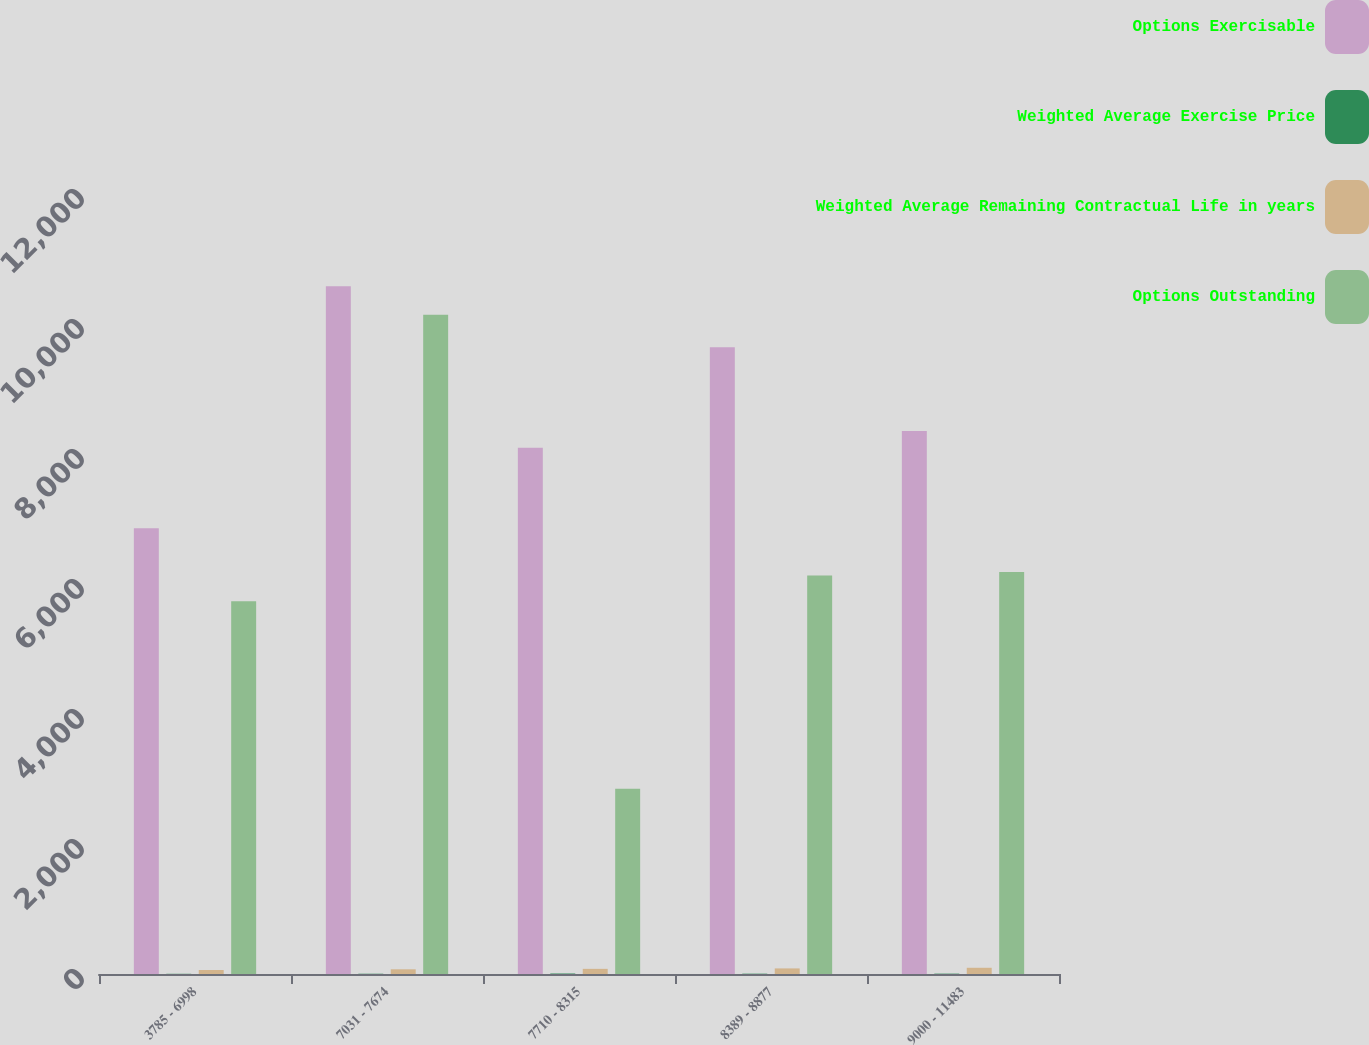Convert chart. <chart><loc_0><loc_0><loc_500><loc_500><stacked_bar_chart><ecel><fcel>3785 - 6998<fcel>7031 - 7674<fcel>7710 - 8315<fcel>8389 - 8877<fcel>9000 - 11483<nl><fcel>Options Exercisable<fcel>6859<fcel>10579<fcel>8095<fcel>9644<fcel>8352<nl><fcel>Weighted Average Exercise Price<fcel>3<fcel>4.1<fcel>7.5<fcel>5<fcel>5.5<nl><fcel>Weighted Average Remaining Contractual Life in years<fcel>61.23<fcel>72.17<fcel>79.34<fcel>85.88<fcel>95.86<nl><fcel>Options Outstanding<fcel>5736<fcel>10144<fcel>2851<fcel>6129<fcel>6186<nl></chart> 